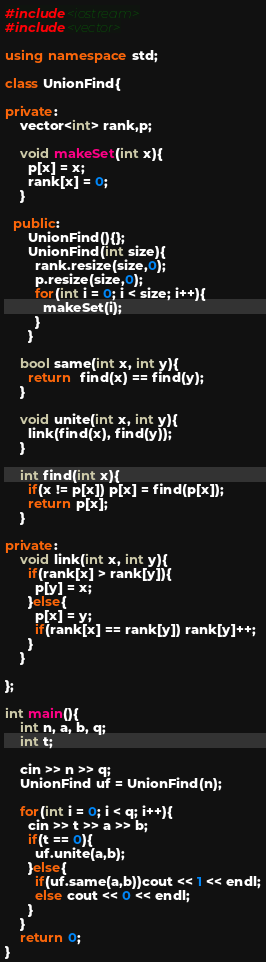Convert code to text. <code><loc_0><loc_0><loc_500><loc_500><_C++_>#include<iostream>
#include<vector>

using namespace std;

class UnionFind{

private:
    vector<int> rank,p;

    void makeSet(int x){
      p[x] = x;
      rank[x] = 0;
    }

  public:
      UnionFind(){};
      UnionFind(int size){
        rank.resize(size,0);
        p.resize(size,0);
        for(int i = 0; i < size; i++){
          makeSet(i);
        }
      }

    bool same(int x, int y){
      return  find(x) == find(y);
    }

    void unite(int x, int y){
      link(find(x), find(y));
    }

    int find(int x){
      if(x != p[x]) p[x] = find(p[x]);
      return p[x];
    }

private:
    void link(int x, int y){
      if(rank[x] > rank[y]){
        p[y] = x;
      }else{
        p[x] = y;
        if(rank[x] == rank[y]) rank[y]++;
      }
    }

};

int main(){
    int n, a, b, q;
    int t;

    cin >> n >> q;
    UnionFind uf = UnionFind(n);

    for(int i = 0; i < q; i++){
      cin >> t >> a >> b;
      if(t == 0){
        uf.unite(a,b);
      }else{
        if(uf.same(a,b))cout << 1 << endl;
        else cout << 0 << endl;
      }
    }
    return 0;
}

</code> 